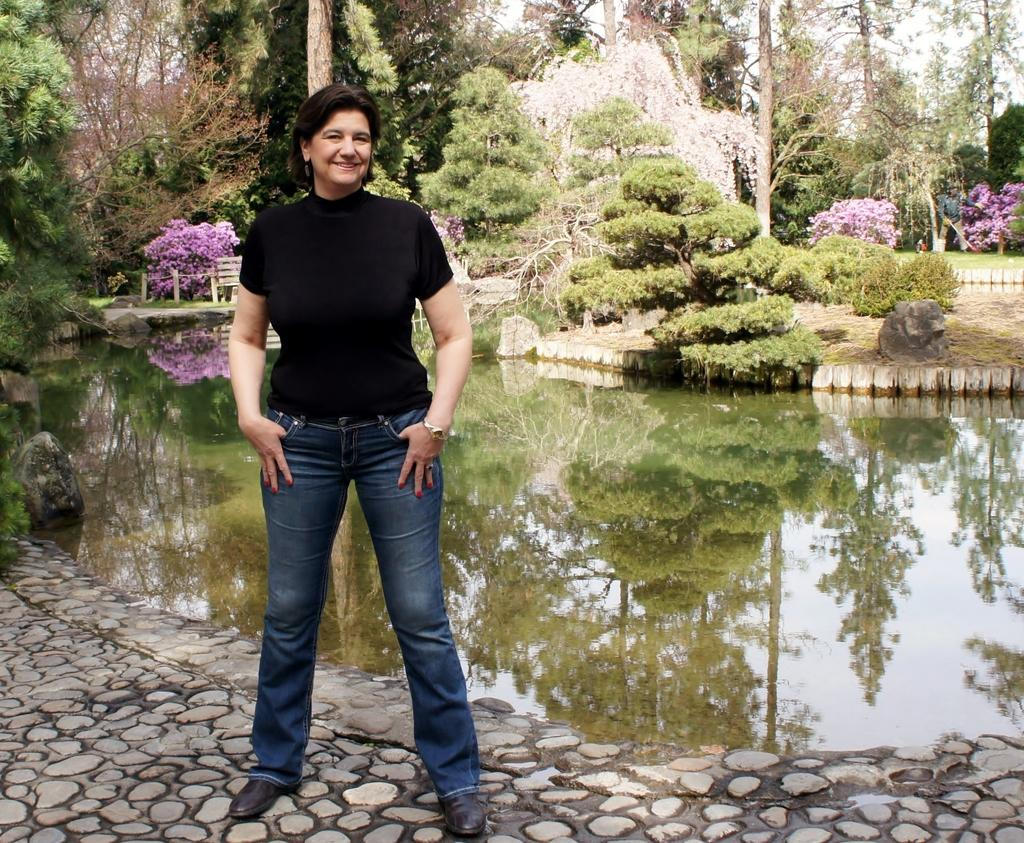What is the main subject of the image? There is a woman standing in the image. What can be seen in the background of the image? There is a bench in the background of the image. What type of natural elements are present in the image? There are trees and water visible in the image. What other objects can be seen in the image? There is a rock in the image. What type of glue is being used by the woman in the image? There is no glue present in the image, and the woman is not using any glue. What achievements has the woman accomplished, as seen in the image? The image does not provide any information about the woman's achievements, so it cannot be determined from the image. 